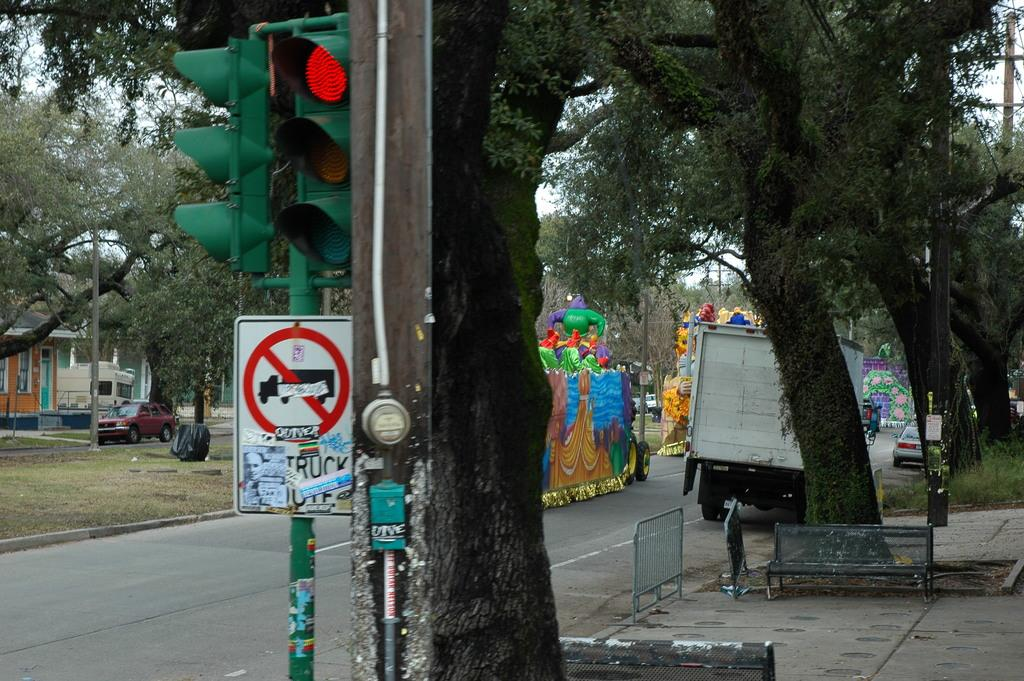What objects can be seen in the foreground of the image? There are poles and a tree in the foreground of the image. What is visible in the background of the image? Trees, toy vehicles, cars, houses, and the sky are visible in the background of the image. Can you describe the objects in the background related to transportation? Toy vehicles and cars are present in the background of the image. What type of structures can be seen in the background of the image? Houses are present in the background of the image. What type of mint is growing on the poles in the image? There is no mint growing on the poles in the image; the poles are not related to any plant or herb. 